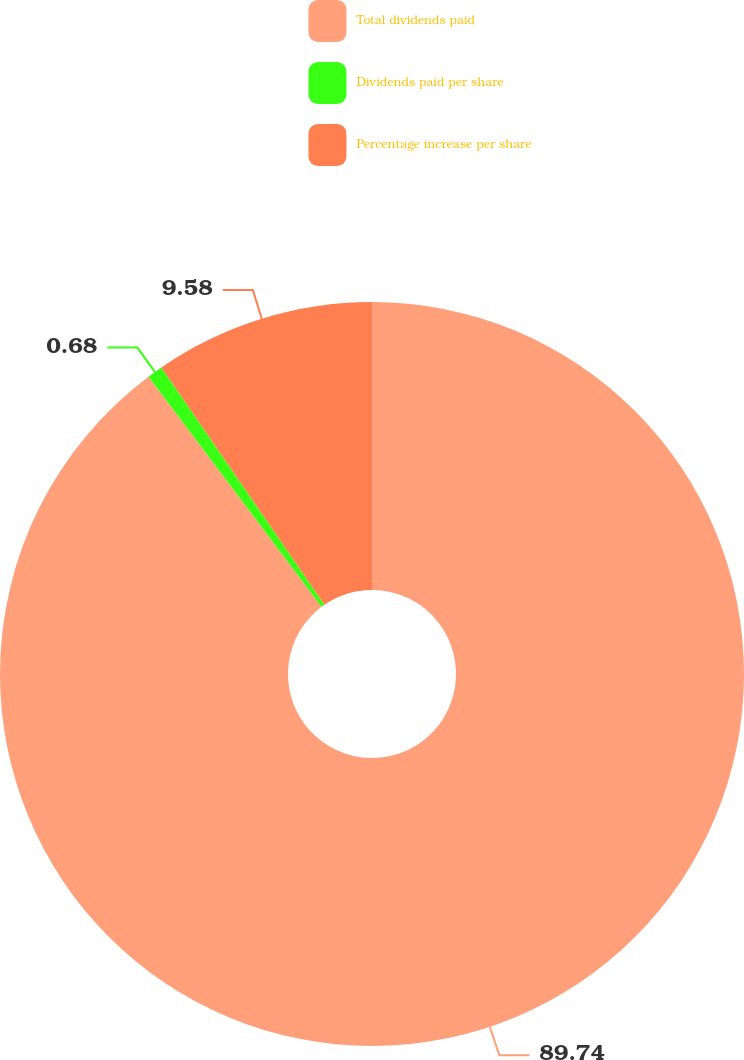Convert chart. <chart><loc_0><loc_0><loc_500><loc_500><pie_chart><fcel>Total dividends paid<fcel>Dividends paid per share<fcel>Percentage increase per share<nl><fcel>89.74%<fcel>0.68%<fcel>9.58%<nl></chart> 